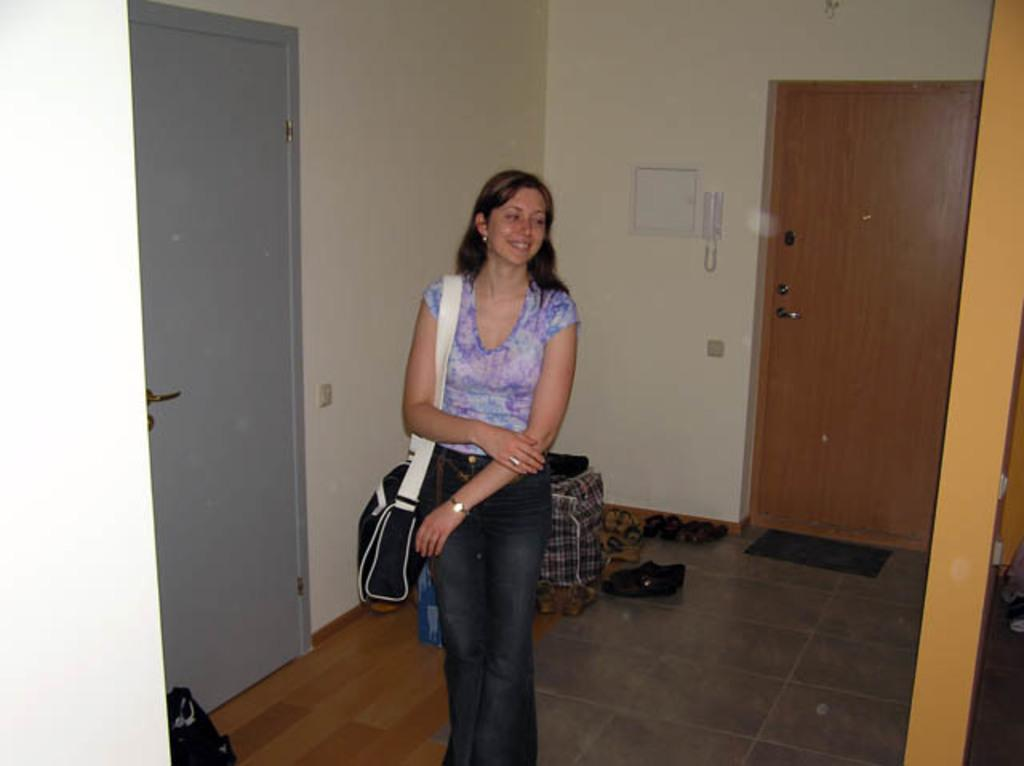Who is the main subject in the image? There is a lady in the center of the image. What is the lady wearing? The lady is wearing a bag. What can be seen in the background of the image? There is a wall and a door in the background of the image. What else is visible in the background? There are many foot wears in the background of the image. Can you tell me how many giraffes are visible in the image? There are no giraffes present in the image; it features a lady in the center and various elements in the background, but no giraffes. 